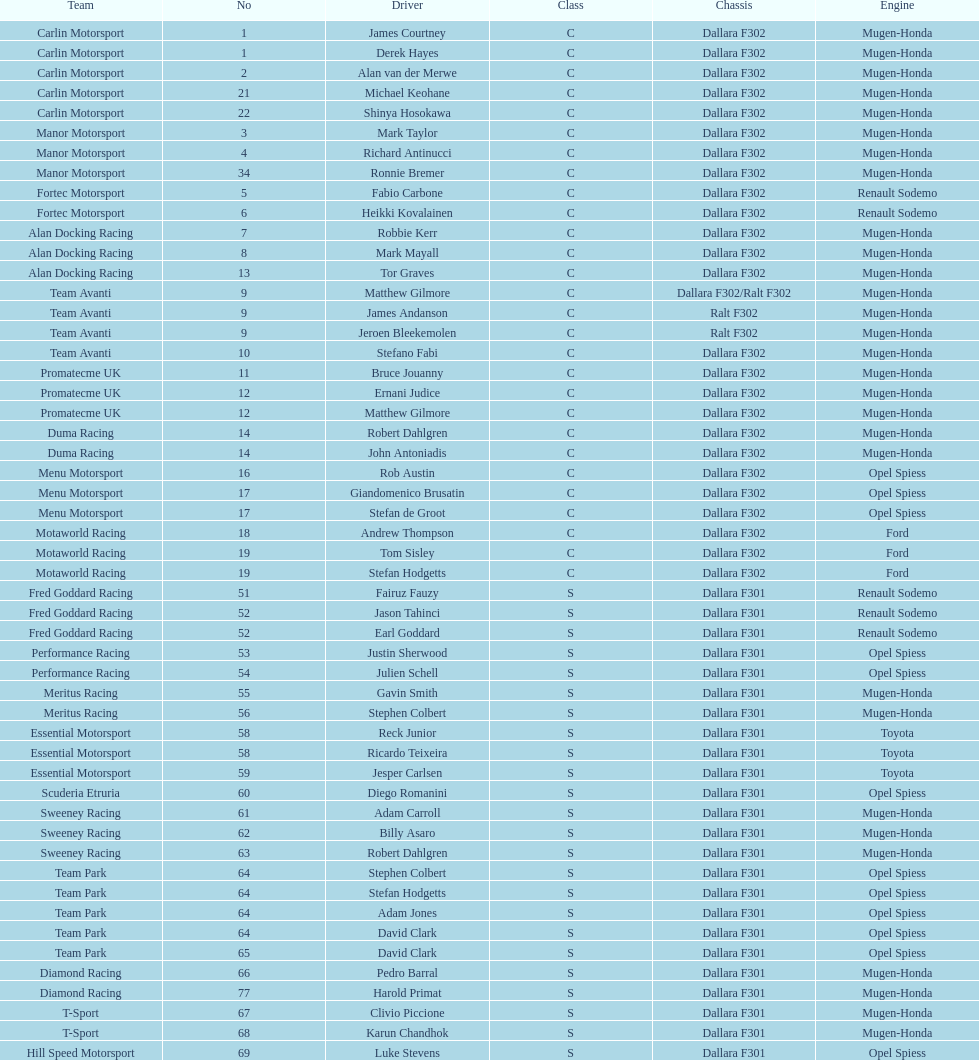How many teams consisted of drivers all belonging to the same country? 4. 